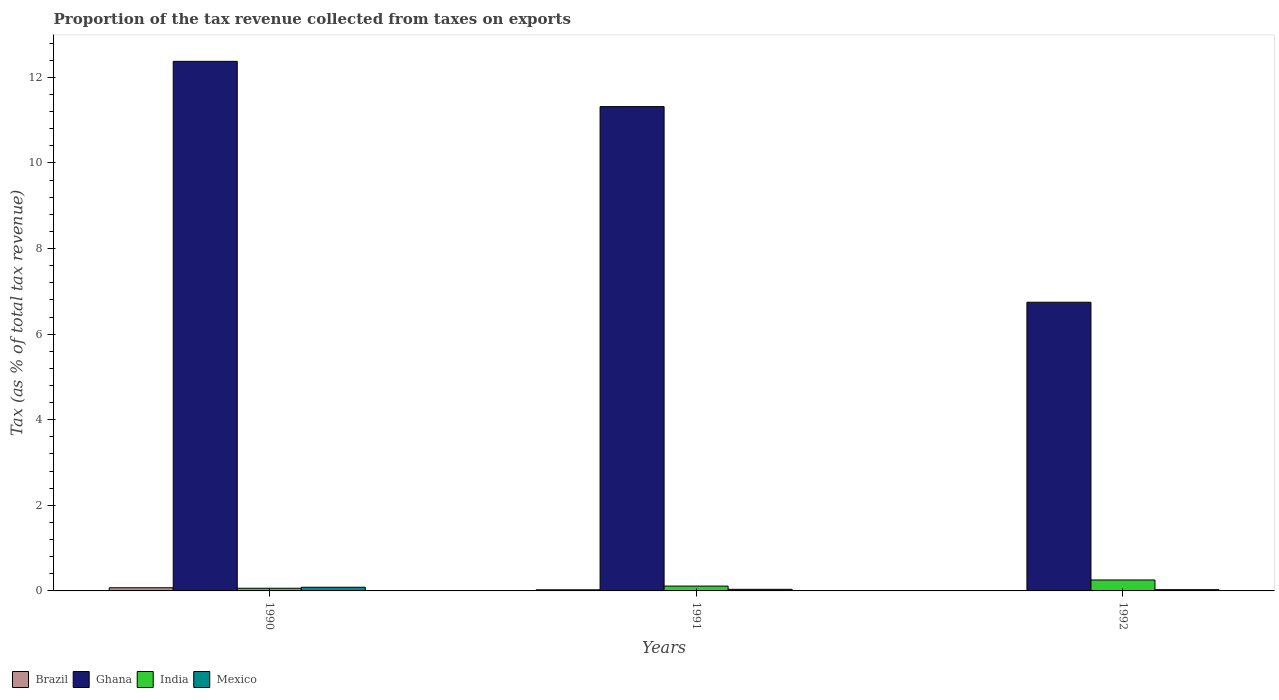How many groups of bars are there?
Offer a very short reply. 3. Are the number of bars per tick equal to the number of legend labels?
Give a very brief answer. Yes. How many bars are there on the 2nd tick from the left?
Give a very brief answer. 4. What is the label of the 3rd group of bars from the left?
Offer a terse response. 1992. In how many cases, is the number of bars for a given year not equal to the number of legend labels?
Provide a succinct answer. 0. What is the proportion of the tax revenue collected in India in 1991?
Ensure brevity in your answer.  0.11. Across all years, what is the maximum proportion of the tax revenue collected in Ghana?
Provide a short and direct response. 12.37. Across all years, what is the minimum proportion of the tax revenue collected in Brazil?
Your response must be concise. 0. What is the total proportion of the tax revenue collected in India in the graph?
Provide a succinct answer. 0.43. What is the difference between the proportion of the tax revenue collected in Brazil in 1991 and that in 1992?
Offer a very short reply. 0.02. What is the difference between the proportion of the tax revenue collected in Mexico in 1991 and the proportion of the tax revenue collected in India in 1990?
Make the answer very short. -0.03. What is the average proportion of the tax revenue collected in Mexico per year?
Make the answer very short. 0.05. In the year 1991, what is the difference between the proportion of the tax revenue collected in Brazil and proportion of the tax revenue collected in Mexico?
Ensure brevity in your answer.  -0.01. What is the ratio of the proportion of the tax revenue collected in Ghana in 1991 to that in 1992?
Provide a short and direct response. 1.68. Is the difference between the proportion of the tax revenue collected in Brazil in 1990 and 1992 greater than the difference between the proportion of the tax revenue collected in Mexico in 1990 and 1992?
Keep it short and to the point. Yes. What is the difference between the highest and the second highest proportion of the tax revenue collected in India?
Keep it short and to the point. 0.14. What is the difference between the highest and the lowest proportion of the tax revenue collected in Brazil?
Your answer should be compact. 0.07. Is it the case that in every year, the sum of the proportion of the tax revenue collected in Brazil and proportion of the tax revenue collected in India is greater than the sum of proportion of the tax revenue collected in Ghana and proportion of the tax revenue collected in Mexico?
Your answer should be compact. Yes. What does the 2nd bar from the left in 1991 represents?
Provide a short and direct response. Ghana. What does the 4th bar from the right in 1990 represents?
Your response must be concise. Brazil. Does the graph contain any zero values?
Your answer should be very brief. No. Does the graph contain grids?
Offer a very short reply. No. Where does the legend appear in the graph?
Offer a terse response. Bottom left. What is the title of the graph?
Keep it short and to the point. Proportion of the tax revenue collected from taxes on exports. What is the label or title of the X-axis?
Offer a terse response. Years. What is the label or title of the Y-axis?
Provide a short and direct response. Tax (as % of total tax revenue). What is the Tax (as % of total tax revenue) of Brazil in 1990?
Your answer should be compact. 0.07. What is the Tax (as % of total tax revenue) of Ghana in 1990?
Keep it short and to the point. 12.37. What is the Tax (as % of total tax revenue) in India in 1990?
Your answer should be very brief. 0.06. What is the Tax (as % of total tax revenue) of Mexico in 1990?
Your response must be concise. 0.09. What is the Tax (as % of total tax revenue) in Brazil in 1991?
Offer a terse response. 0.03. What is the Tax (as % of total tax revenue) of Ghana in 1991?
Provide a succinct answer. 11.32. What is the Tax (as % of total tax revenue) of India in 1991?
Your response must be concise. 0.11. What is the Tax (as % of total tax revenue) in Mexico in 1991?
Make the answer very short. 0.04. What is the Tax (as % of total tax revenue) in Brazil in 1992?
Offer a terse response. 0. What is the Tax (as % of total tax revenue) in Ghana in 1992?
Your answer should be compact. 6.75. What is the Tax (as % of total tax revenue) in India in 1992?
Give a very brief answer. 0.26. What is the Tax (as % of total tax revenue) in Mexico in 1992?
Offer a terse response. 0.03. Across all years, what is the maximum Tax (as % of total tax revenue) in Brazil?
Make the answer very short. 0.07. Across all years, what is the maximum Tax (as % of total tax revenue) in Ghana?
Your answer should be very brief. 12.37. Across all years, what is the maximum Tax (as % of total tax revenue) in India?
Provide a succinct answer. 0.26. Across all years, what is the maximum Tax (as % of total tax revenue) of Mexico?
Ensure brevity in your answer.  0.09. Across all years, what is the minimum Tax (as % of total tax revenue) of Brazil?
Provide a succinct answer. 0. Across all years, what is the minimum Tax (as % of total tax revenue) in Ghana?
Offer a terse response. 6.75. Across all years, what is the minimum Tax (as % of total tax revenue) of India?
Your answer should be very brief. 0.06. Across all years, what is the minimum Tax (as % of total tax revenue) of Mexico?
Your answer should be compact. 0.03. What is the total Tax (as % of total tax revenue) in Brazil in the graph?
Your answer should be compact. 0.1. What is the total Tax (as % of total tax revenue) of Ghana in the graph?
Provide a succinct answer. 30.44. What is the total Tax (as % of total tax revenue) of India in the graph?
Provide a short and direct response. 0.43. What is the total Tax (as % of total tax revenue) in Mexico in the graph?
Your response must be concise. 0.15. What is the difference between the Tax (as % of total tax revenue) in Brazil in 1990 and that in 1991?
Keep it short and to the point. 0.05. What is the difference between the Tax (as % of total tax revenue) of Ghana in 1990 and that in 1991?
Provide a succinct answer. 1.06. What is the difference between the Tax (as % of total tax revenue) of India in 1990 and that in 1991?
Make the answer very short. -0.05. What is the difference between the Tax (as % of total tax revenue) of Mexico in 1990 and that in 1991?
Make the answer very short. 0.05. What is the difference between the Tax (as % of total tax revenue) in Brazil in 1990 and that in 1992?
Provide a succinct answer. 0.07. What is the difference between the Tax (as % of total tax revenue) of Ghana in 1990 and that in 1992?
Your answer should be compact. 5.63. What is the difference between the Tax (as % of total tax revenue) in India in 1990 and that in 1992?
Your answer should be compact. -0.19. What is the difference between the Tax (as % of total tax revenue) of Mexico in 1990 and that in 1992?
Your answer should be very brief. 0.06. What is the difference between the Tax (as % of total tax revenue) of Brazil in 1991 and that in 1992?
Give a very brief answer. 0.02. What is the difference between the Tax (as % of total tax revenue) of Ghana in 1991 and that in 1992?
Provide a short and direct response. 4.57. What is the difference between the Tax (as % of total tax revenue) in India in 1991 and that in 1992?
Provide a short and direct response. -0.14. What is the difference between the Tax (as % of total tax revenue) of Mexico in 1991 and that in 1992?
Provide a succinct answer. 0.01. What is the difference between the Tax (as % of total tax revenue) in Brazil in 1990 and the Tax (as % of total tax revenue) in Ghana in 1991?
Your response must be concise. -11.24. What is the difference between the Tax (as % of total tax revenue) in Brazil in 1990 and the Tax (as % of total tax revenue) in India in 1991?
Ensure brevity in your answer.  -0.04. What is the difference between the Tax (as % of total tax revenue) of Brazil in 1990 and the Tax (as % of total tax revenue) of Mexico in 1991?
Your answer should be very brief. 0.04. What is the difference between the Tax (as % of total tax revenue) in Ghana in 1990 and the Tax (as % of total tax revenue) in India in 1991?
Ensure brevity in your answer.  12.26. What is the difference between the Tax (as % of total tax revenue) in Ghana in 1990 and the Tax (as % of total tax revenue) in Mexico in 1991?
Your answer should be very brief. 12.34. What is the difference between the Tax (as % of total tax revenue) of India in 1990 and the Tax (as % of total tax revenue) of Mexico in 1991?
Offer a terse response. 0.03. What is the difference between the Tax (as % of total tax revenue) in Brazil in 1990 and the Tax (as % of total tax revenue) in Ghana in 1992?
Make the answer very short. -6.67. What is the difference between the Tax (as % of total tax revenue) in Brazil in 1990 and the Tax (as % of total tax revenue) in India in 1992?
Ensure brevity in your answer.  -0.18. What is the difference between the Tax (as % of total tax revenue) of Brazil in 1990 and the Tax (as % of total tax revenue) of Mexico in 1992?
Keep it short and to the point. 0.04. What is the difference between the Tax (as % of total tax revenue) of Ghana in 1990 and the Tax (as % of total tax revenue) of India in 1992?
Offer a very short reply. 12.12. What is the difference between the Tax (as % of total tax revenue) of Ghana in 1990 and the Tax (as % of total tax revenue) of Mexico in 1992?
Your response must be concise. 12.35. What is the difference between the Tax (as % of total tax revenue) of India in 1990 and the Tax (as % of total tax revenue) of Mexico in 1992?
Ensure brevity in your answer.  0.03. What is the difference between the Tax (as % of total tax revenue) of Brazil in 1991 and the Tax (as % of total tax revenue) of Ghana in 1992?
Provide a succinct answer. -6.72. What is the difference between the Tax (as % of total tax revenue) in Brazil in 1991 and the Tax (as % of total tax revenue) in India in 1992?
Provide a succinct answer. -0.23. What is the difference between the Tax (as % of total tax revenue) in Brazil in 1991 and the Tax (as % of total tax revenue) in Mexico in 1992?
Offer a terse response. -0. What is the difference between the Tax (as % of total tax revenue) in Ghana in 1991 and the Tax (as % of total tax revenue) in India in 1992?
Provide a succinct answer. 11.06. What is the difference between the Tax (as % of total tax revenue) in Ghana in 1991 and the Tax (as % of total tax revenue) in Mexico in 1992?
Your response must be concise. 11.29. What is the difference between the Tax (as % of total tax revenue) of India in 1991 and the Tax (as % of total tax revenue) of Mexico in 1992?
Make the answer very short. 0.08. What is the average Tax (as % of total tax revenue) of Brazil per year?
Give a very brief answer. 0.03. What is the average Tax (as % of total tax revenue) of Ghana per year?
Your answer should be compact. 10.15. What is the average Tax (as % of total tax revenue) in India per year?
Ensure brevity in your answer.  0.14. What is the average Tax (as % of total tax revenue) in Mexico per year?
Keep it short and to the point. 0.05. In the year 1990, what is the difference between the Tax (as % of total tax revenue) of Brazil and Tax (as % of total tax revenue) of Ghana?
Ensure brevity in your answer.  -12.3. In the year 1990, what is the difference between the Tax (as % of total tax revenue) of Brazil and Tax (as % of total tax revenue) of India?
Ensure brevity in your answer.  0.01. In the year 1990, what is the difference between the Tax (as % of total tax revenue) of Brazil and Tax (as % of total tax revenue) of Mexico?
Ensure brevity in your answer.  -0.01. In the year 1990, what is the difference between the Tax (as % of total tax revenue) in Ghana and Tax (as % of total tax revenue) in India?
Your answer should be compact. 12.31. In the year 1990, what is the difference between the Tax (as % of total tax revenue) in Ghana and Tax (as % of total tax revenue) in Mexico?
Your response must be concise. 12.29. In the year 1990, what is the difference between the Tax (as % of total tax revenue) in India and Tax (as % of total tax revenue) in Mexico?
Keep it short and to the point. -0.02. In the year 1991, what is the difference between the Tax (as % of total tax revenue) of Brazil and Tax (as % of total tax revenue) of Ghana?
Your answer should be compact. -11.29. In the year 1991, what is the difference between the Tax (as % of total tax revenue) in Brazil and Tax (as % of total tax revenue) in India?
Provide a short and direct response. -0.09. In the year 1991, what is the difference between the Tax (as % of total tax revenue) in Brazil and Tax (as % of total tax revenue) in Mexico?
Your response must be concise. -0.01. In the year 1991, what is the difference between the Tax (as % of total tax revenue) of Ghana and Tax (as % of total tax revenue) of India?
Your answer should be compact. 11.2. In the year 1991, what is the difference between the Tax (as % of total tax revenue) of Ghana and Tax (as % of total tax revenue) of Mexico?
Provide a succinct answer. 11.28. In the year 1991, what is the difference between the Tax (as % of total tax revenue) in India and Tax (as % of total tax revenue) in Mexico?
Make the answer very short. 0.08. In the year 1992, what is the difference between the Tax (as % of total tax revenue) in Brazil and Tax (as % of total tax revenue) in Ghana?
Your response must be concise. -6.74. In the year 1992, what is the difference between the Tax (as % of total tax revenue) in Brazil and Tax (as % of total tax revenue) in India?
Ensure brevity in your answer.  -0.25. In the year 1992, what is the difference between the Tax (as % of total tax revenue) in Brazil and Tax (as % of total tax revenue) in Mexico?
Keep it short and to the point. -0.03. In the year 1992, what is the difference between the Tax (as % of total tax revenue) of Ghana and Tax (as % of total tax revenue) of India?
Make the answer very short. 6.49. In the year 1992, what is the difference between the Tax (as % of total tax revenue) in Ghana and Tax (as % of total tax revenue) in Mexico?
Your answer should be compact. 6.72. In the year 1992, what is the difference between the Tax (as % of total tax revenue) of India and Tax (as % of total tax revenue) of Mexico?
Your answer should be compact. 0.23. What is the ratio of the Tax (as % of total tax revenue) in Brazil in 1990 to that in 1991?
Give a very brief answer. 2.76. What is the ratio of the Tax (as % of total tax revenue) of Ghana in 1990 to that in 1991?
Make the answer very short. 1.09. What is the ratio of the Tax (as % of total tax revenue) of India in 1990 to that in 1991?
Offer a terse response. 0.55. What is the ratio of the Tax (as % of total tax revenue) of Mexico in 1990 to that in 1991?
Your answer should be very brief. 2.3. What is the ratio of the Tax (as % of total tax revenue) in Brazil in 1990 to that in 1992?
Provide a succinct answer. 38.17. What is the ratio of the Tax (as % of total tax revenue) in Ghana in 1990 to that in 1992?
Offer a terse response. 1.83. What is the ratio of the Tax (as % of total tax revenue) of India in 1990 to that in 1992?
Your response must be concise. 0.24. What is the ratio of the Tax (as % of total tax revenue) of Mexico in 1990 to that in 1992?
Make the answer very short. 2.96. What is the ratio of the Tax (as % of total tax revenue) in Brazil in 1991 to that in 1992?
Offer a terse response. 13.82. What is the ratio of the Tax (as % of total tax revenue) of Ghana in 1991 to that in 1992?
Your response must be concise. 1.68. What is the ratio of the Tax (as % of total tax revenue) in India in 1991 to that in 1992?
Provide a short and direct response. 0.44. What is the ratio of the Tax (as % of total tax revenue) of Mexico in 1991 to that in 1992?
Your response must be concise. 1.28. What is the difference between the highest and the second highest Tax (as % of total tax revenue) in Brazil?
Your answer should be very brief. 0.05. What is the difference between the highest and the second highest Tax (as % of total tax revenue) of Ghana?
Your response must be concise. 1.06. What is the difference between the highest and the second highest Tax (as % of total tax revenue) of India?
Give a very brief answer. 0.14. What is the difference between the highest and the second highest Tax (as % of total tax revenue) in Mexico?
Your answer should be compact. 0.05. What is the difference between the highest and the lowest Tax (as % of total tax revenue) of Brazil?
Offer a terse response. 0.07. What is the difference between the highest and the lowest Tax (as % of total tax revenue) of Ghana?
Your answer should be compact. 5.63. What is the difference between the highest and the lowest Tax (as % of total tax revenue) in India?
Ensure brevity in your answer.  0.19. What is the difference between the highest and the lowest Tax (as % of total tax revenue) in Mexico?
Give a very brief answer. 0.06. 